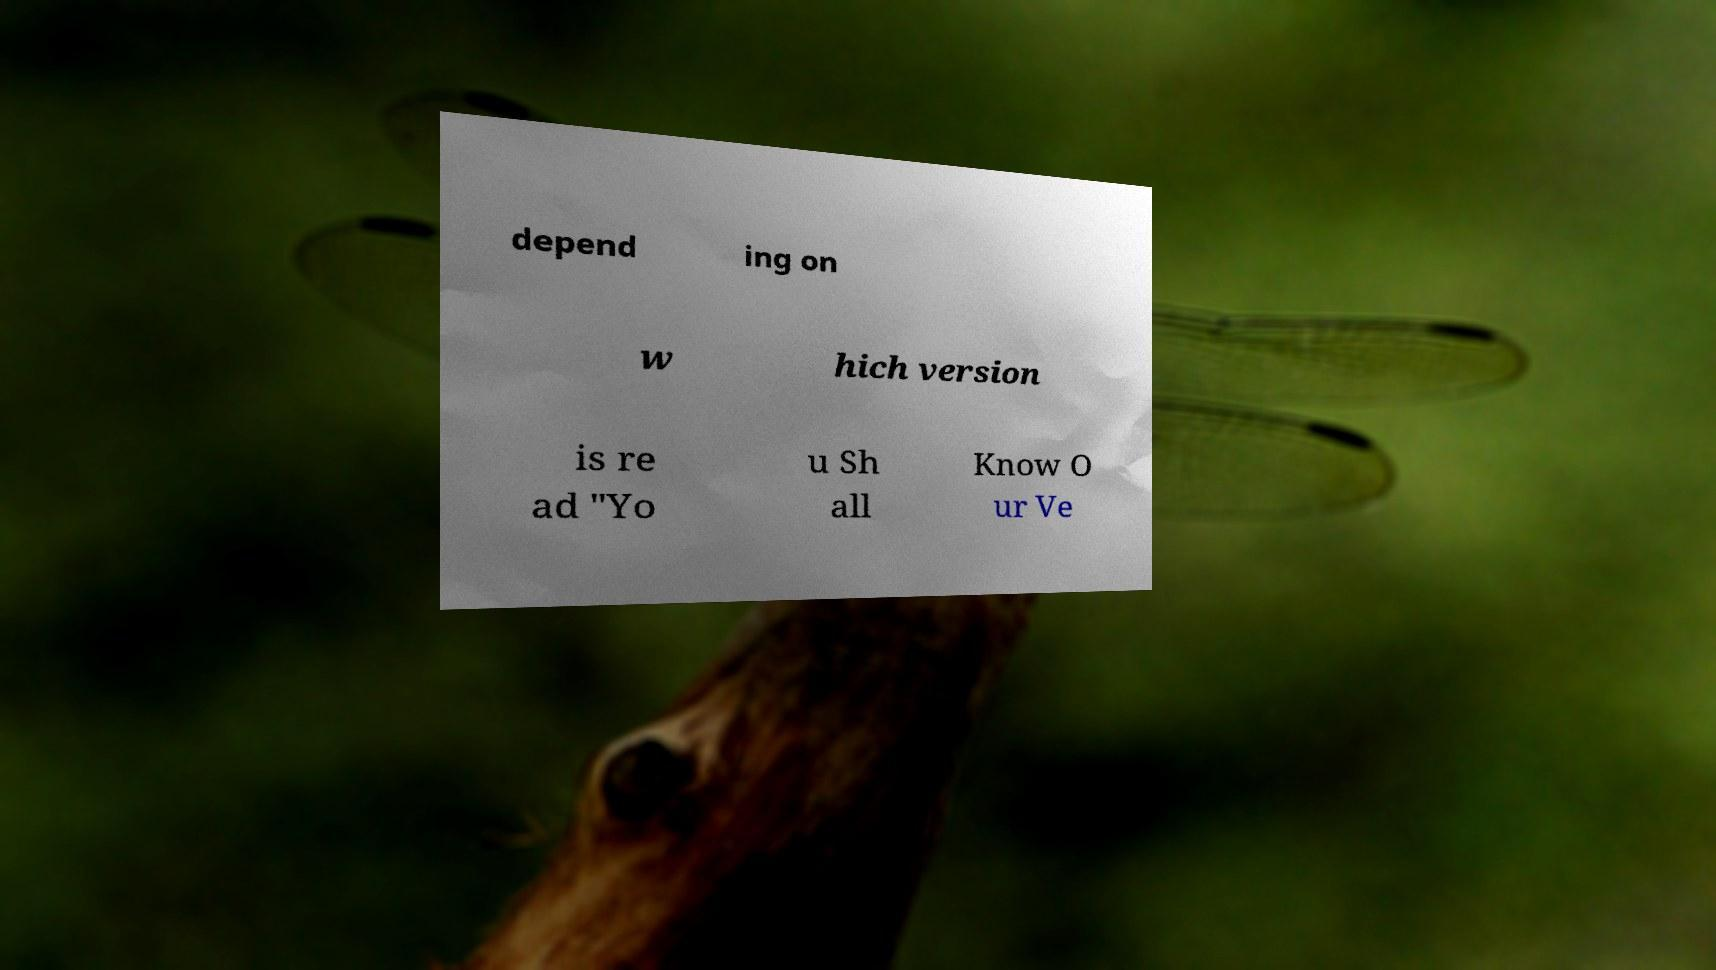Please identify and transcribe the text found in this image. depend ing on w hich version is re ad "Yo u Sh all Know O ur Ve 